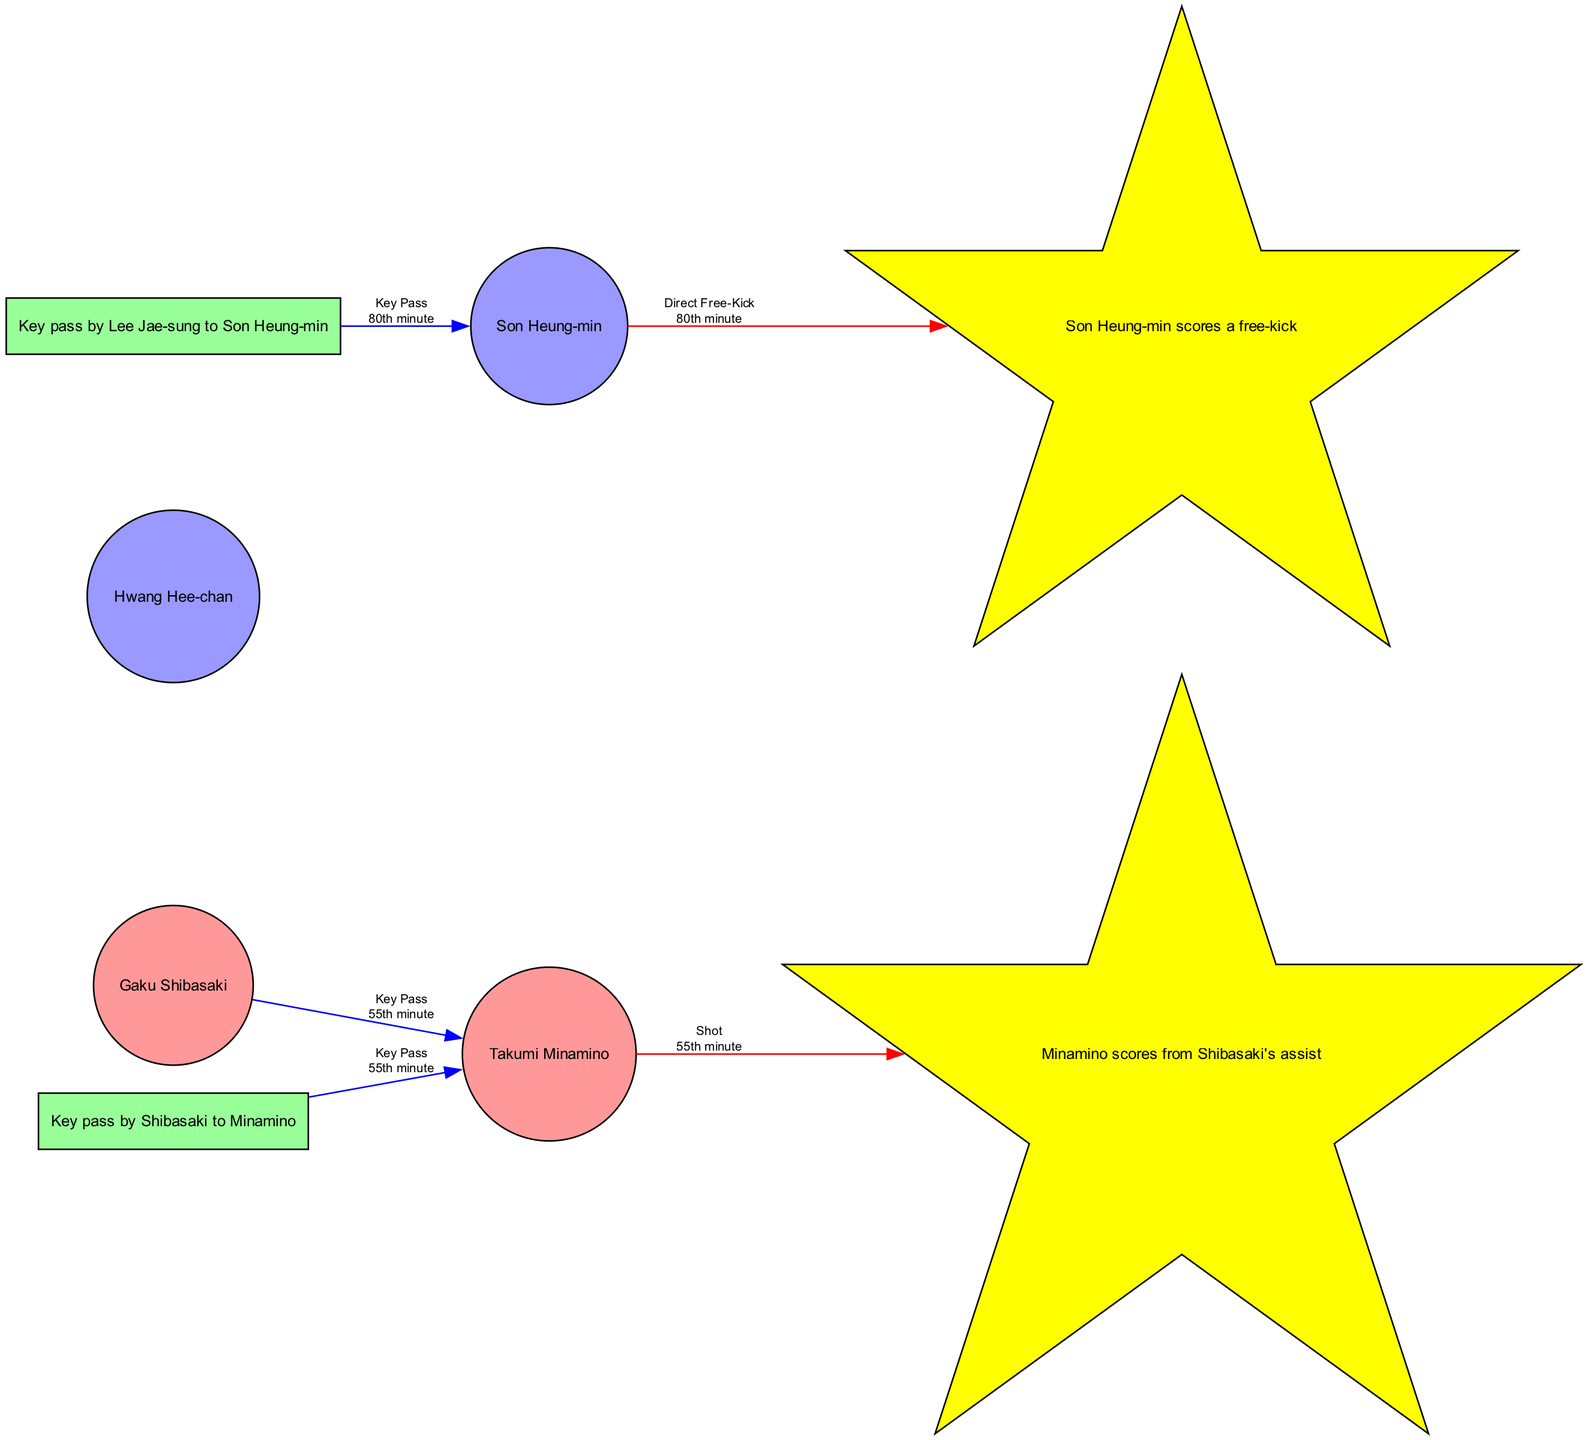What is the total number of players involved in the match? The diagram shows four players: Takumi Minamino, Hwang Hee-chan, Gaku Shibasaki, and Son Heung-min.
Answer: 4 What type of goal did Son Heung-min score? The diagram indicates Son Heung-min scored a goal from a direct free-kick, which is labeled clearly in the edge description.
Answer: Direct Free-Kick Which player assisted Takumi Minamino's goal? The diagram connects Gaku Shibasaki to Takumi Minamino with a labeled edge indicating that Shibasaki provided an assist to Minamino.
Answer: Gaku Shibasaki How many goals were scored in total during this match? The diagram lists two goals: one from Takumi Minamino and one from Son Heung-min, therefore the total is two.
Answer: 2 What minute did Minamino score his goal? The diagram notes that Minamino's goal occurred at the 55th minute, as mentioned in the goal description.
Answer: 55th minute Which team did Gaku Shibasaki play for? According to the node information in the diagram, Gaku Shibasaki is identified as a player of the Japan team.
Answer: Japan Who made the key pass to Son Heung-min? The diagram shows an edge from Lee Jae-sung to Son Heung-min, identifying Lee as the player who made the key pass.
Answer: Lee Jae-sung In what minute did the key pass from Shibasaki to Minamino occur? The edge connecting Shibasaki to Minamino indicates that the key pass took place at the 55th minute, aligning with the goal scored by Minamino.
Answer: 55th minute How many key passes were made in the match? The diagram identifies two key passes: one from Shibasaki to Minamino and another from Lee Jae-sung to Son Heung-min, resulting in a total of two.
Answer: 2 